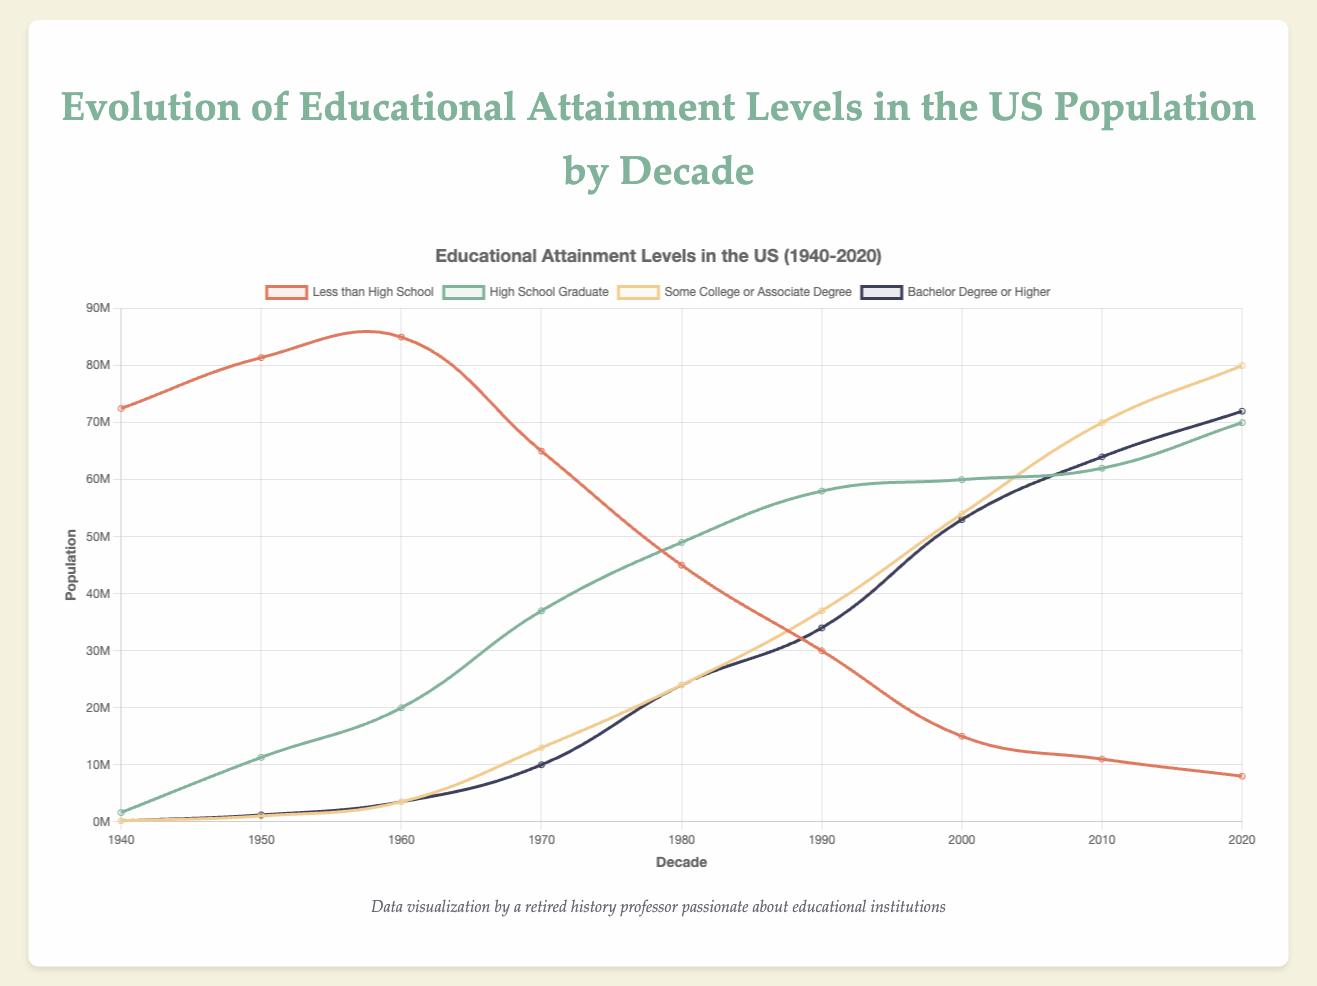What trend is noticeable in the population with less than a high school education from 1940 to 2020? The population with less than a high school education decreases significantly over the decades. It starts at 72.48 million in 1940 and drops to 8 million by 2020, indicating an increasing level of education among the population.
Answer: It decreases significantly How does the number of high school graduates in 1970 compare to 1960? In 1960, there were 20 million high school graduates, while in 1970, the number increased to 37 million. By subtracting the 1960 value from the 1970 value (37M - 20M), we see an increase of 17 million.
Answer: It increased by 17 million Which educational attainment category saw the most significant increase between 1980 and 1990? The category of "Bachelor Degree or Higher" saw the most significant increase. In 1980, it was 24 million, and in 1990, it rose to 34 million. Calculating the difference (34M - 24M) shows an increase of 10 million.
Answer: Bachelor Degree or Higher What was the population with some college or an associate degree in 2000 compared to 2020? In 2000, the population with some college or an associate degree was 54 million, while in 2020, it was 80 million. Subtracting the 2000 value from the 2020 value (80M - 54M) gives an increase of 26 million.
Answer: It increased by 26 million What color represents the "Bachelor Degree or Higher" category in the chart? The "Bachelor Degree or Higher" category is represented by the dark blue color, as identified by the key in the chart.
Answer: Dark blue Combine the populations of high school graduates and those with a bachelor's degree or higher in 2010. How does it compare to the total population for that year? In 2010, high school graduates were at 62 million, and those with a bachelor's degree or higher were at 64 million. Adding them together (62M + 64M) gives 126 million. The total population that year was 207 million. Comparing these, 126 million is a substantial portion of the total population.
Answer: 126 million vs. 207 million What can be observed about the trend for individuals with some college or an associate degree from 1980 onwards? From 1980 onwards, the population with some college or an associate degree shows a steadily rising trend. It increased from 24 million in 1980 to 80 million in 2020, displaying continuous growth over the decades.
Answer: Steadily rising In which decade did the number of people with less than a high school education drop below the number of high school graduates? The number of people with less than a high school education dropped below the number of high school graduates in the 1970s. In 1970, the population with less than a high school education was 65 million, while high school graduates were at 37 million. By the 1980s, less than high school was 45 million, and high school graduates were 49 million.
Answer: 1980s 